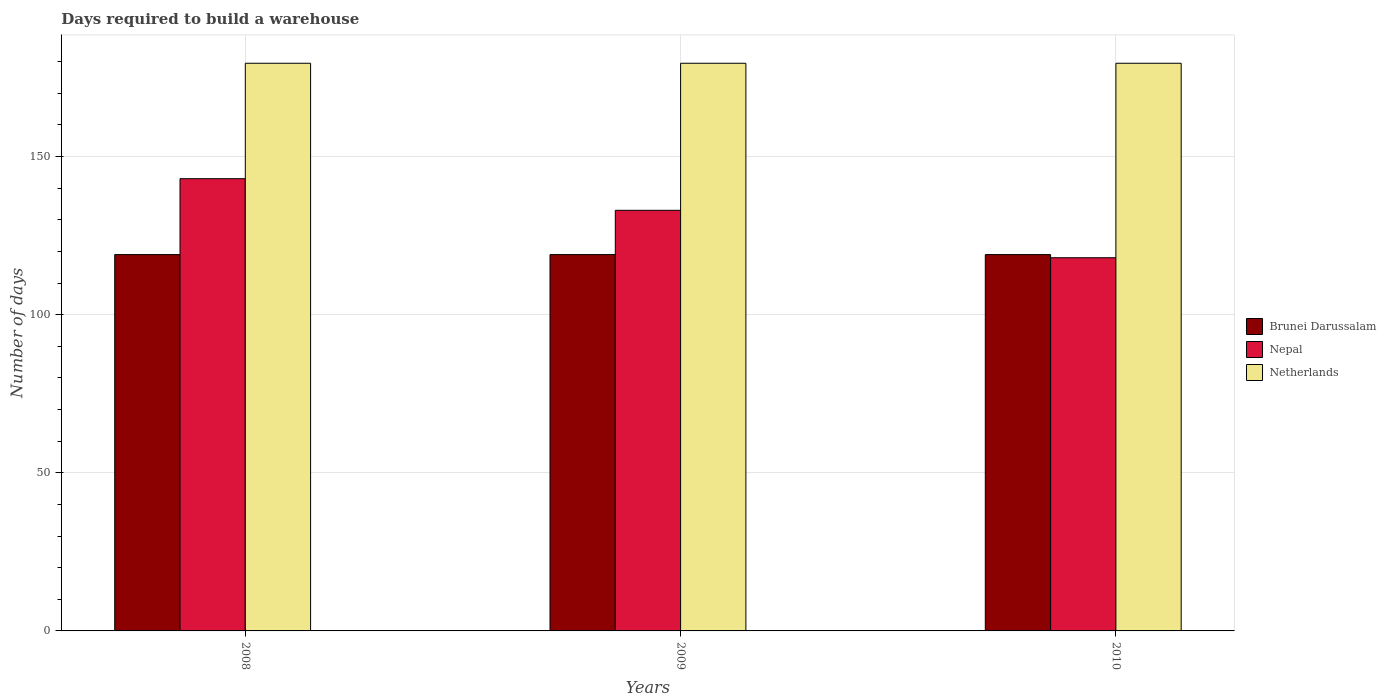How many different coloured bars are there?
Make the answer very short. 3. How many groups of bars are there?
Make the answer very short. 3. Are the number of bars per tick equal to the number of legend labels?
Your answer should be compact. Yes. How many bars are there on the 1st tick from the left?
Offer a very short reply. 3. What is the label of the 3rd group of bars from the left?
Your response must be concise. 2010. In how many cases, is the number of bars for a given year not equal to the number of legend labels?
Your response must be concise. 0. What is the days required to build a warehouse in in Brunei Darussalam in 2008?
Your answer should be compact. 119. Across all years, what is the maximum days required to build a warehouse in in Brunei Darussalam?
Your answer should be very brief. 119. Across all years, what is the minimum days required to build a warehouse in in Brunei Darussalam?
Keep it short and to the point. 119. In which year was the days required to build a warehouse in in Brunei Darussalam minimum?
Give a very brief answer. 2008. What is the total days required to build a warehouse in in Netherlands in the graph?
Give a very brief answer. 538.5. What is the average days required to build a warehouse in in Netherlands per year?
Make the answer very short. 179.5. In the year 2010, what is the difference between the days required to build a warehouse in in Brunei Darussalam and days required to build a warehouse in in Netherlands?
Make the answer very short. -60.5. In how many years, is the days required to build a warehouse in in Brunei Darussalam greater than 40 days?
Your answer should be very brief. 3. Is the days required to build a warehouse in in Nepal in 2008 less than that in 2010?
Offer a terse response. No. Is the difference between the days required to build a warehouse in in Brunei Darussalam in 2008 and 2009 greater than the difference between the days required to build a warehouse in in Netherlands in 2008 and 2009?
Provide a short and direct response. No. What does the 2nd bar from the left in 2010 represents?
Make the answer very short. Nepal. What does the 2nd bar from the right in 2009 represents?
Your answer should be compact. Nepal. Is it the case that in every year, the sum of the days required to build a warehouse in in Netherlands and days required to build a warehouse in in Nepal is greater than the days required to build a warehouse in in Brunei Darussalam?
Offer a terse response. Yes. Where does the legend appear in the graph?
Your response must be concise. Center right. What is the title of the graph?
Give a very brief answer. Days required to build a warehouse. Does "Qatar" appear as one of the legend labels in the graph?
Ensure brevity in your answer.  No. What is the label or title of the X-axis?
Keep it short and to the point. Years. What is the label or title of the Y-axis?
Offer a terse response. Number of days. What is the Number of days of Brunei Darussalam in 2008?
Offer a terse response. 119. What is the Number of days of Nepal in 2008?
Offer a very short reply. 143. What is the Number of days of Netherlands in 2008?
Keep it short and to the point. 179.5. What is the Number of days in Brunei Darussalam in 2009?
Keep it short and to the point. 119. What is the Number of days of Nepal in 2009?
Your answer should be very brief. 133. What is the Number of days of Netherlands in 2009?
Make the answer very short. 179.5. What is the Number of days of Brunei Darussalam in 2010?
Provide a short and direct response. 119. What is the Number of days in Nepal in 2010?
Your response must be concise. 118. What is the Number of days in Netherlands in 2010?
Offer a very short reply. 179.5. Across all years, what is the maximum Number of days of Brunei Darussalam?
Offer a very short reply. 119. Across all years, what is the maximum Number of days in Nepal?
Provide a succinct answer. 143. Across all years, what is the maximum Number of days of Netherlands?
Provide a short and direct response. 179.5. Across all years, what is the minimum Number of days of Brunei Darussalam?
Provide a succinct answer. 119. Across all years, what is the minimum Number of days in Nepal?
Your response must be concise. 118. Across all years, what is the minimum Number of days in Netherlands?
Make the answer very short. 179.5. What is the total Number of days in Brunei Darussalam in the graph?
Keep it short and to the point. 357. What is the total Number of days in Nepal in the graph?
Provide a succinct answer. 394. What is the total Number of days of Netherlands in the graph?
Make the answer very short. 538.5. What is the difference between the Number of days in Brunei Darussalam in 2008 and that in 2010?
Your answer should be very brief. 0. What is the difference between the Number of days of Nepal in 2008 and that in 2010?
Offer a terse response. 25. What is the difference between the Number of days of Netherlands in 2008 and that in 2010?
Keep it short and to the point. 0. What is the difference between the Number of days in Brunei Darussalam in 2009 and that in 2010?
Your answer should be very brief. 0. What is the difference between the Number of days in Netherlands in 2009 and that in 2010?
Give a very brief answer. 0. What is the difference between the Number of days in Brunei Darussalam in 2008 and the Number of days in Nepal in 2009?
Offer a terse response. -14. What is the difference between the Number of days in Brunei Darussalam in 2008 and the Number of days in Netherlands in 2009?
Provide a succinct answer. -60.5. What is the difference between the Number of days of Nepal in 2008 and the Number of days of Netherlands in 2009?
Provide a short and direct response. -36.5. What is the difference between the Number of days in Brunei Darussalam in 2008 and the Number of days in Netherlands in 2010?
Provide a succinct answer. -60.5. What is the difference between the Number of days in Nepal in 2008 and the Number of days in Netherlands in 2010?
Your answer should be compact. -36.5. What is the difference between the Number of days in Brunei Darussalam in 2009 and the Number of days in Nepal in 2010?
Provide a succinct answer. 1. What is the difference between the Number of days in Brunei Darussalam in 2009 and the Number of days in Netherlands in 2010?
Offer a terse response. -60.5. What is the difference between the Number of days of Nepal in 2009 and the Number of days of Netherlands in 2010?
Your response must be concise. -46.5. What is the average Number of days of Brunei Darussalam per year?
Give a very brief answer. 119. What is the average Number of days of Nepal per year?
Ensure brevity in your answer.  131.33. What is the average Number of days in Netherlands per year?
Offer a very short reply. 179.5. In the year 2008, what is the difference between the Number of days in Brunei Darussalam and Number of days in Netherlands?
Your answer should be very brief. -60.5. In the year 2008, what is the difference between the Number of days in Nepal and Number of days in Netherlands?
Provide a succinct answer. -36.5. In the year 2009, what is the difference between the Number of days in Brunei Darussalam and Number of days in Nepal?
Provide a short and direct response. -14. In the year 2009, what is the difference between the Number of days of Brunei Darussalam and Number of days of Netherlands?
Your answer should be very brief. -60.5. In the year 2009, what is the difference between the Number of days in Nepal and Number of days in Netherlands?
Your answer should be compact. -46.5. In the year 2010, what is the difference between the Number of days of Brunei Darussalam and Number of days of Netherlands?
Offer a terse response. -60.5. In the year 2010, what is the difference between the Number of days in Nepal and Number of days in Netherlands?
Your answer should be compact. -61.5. What is the ratio of the Number of days in Brunei Darussalam in 2008 to that in 2009?
Offer a very short reply. 1. What is the ratio of the Number of days of Nepal in 2008 to that in 2009?
Make the answer very short. 1.08. What is the ratio of the Number of days in Brunei Darussalam in 2008 to that in 2010?
Make the answer very short. 1. What is the ratio of the Number of days of Nepal in 2008 to that in 2010?
Your answer should be very brief. 1.21. What is the ratio of the Number of days of Nepal in 2009 to that in 2010?
Provide a short and direct response. 1.13. What is the ratio of the Number of days of Netherlands in 2009 to that in 2010?
Make the answer very short. 1. What is the difference between the highest and the second highest Number of days in Nepal?
Ensure brevity in your answer.  10. 